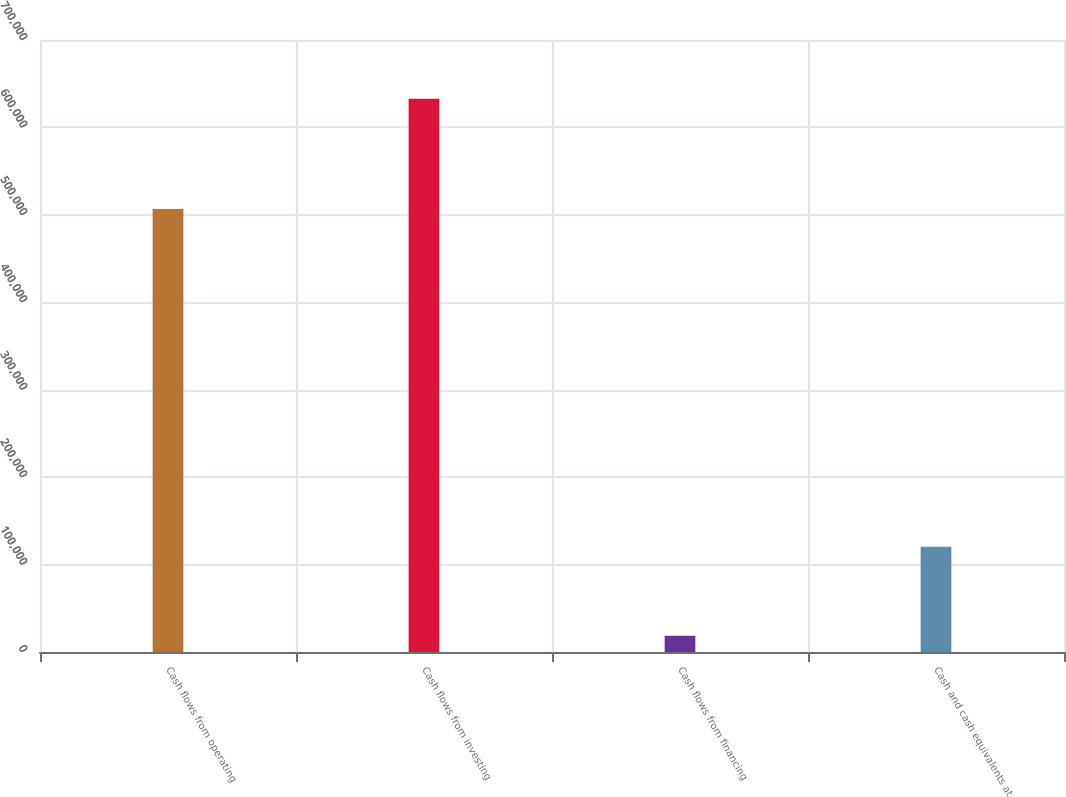Convert chart. <chart><loc_0><loc_0><loc_500><loc_500><bar_chart><fcel>Cash flows from operating<fcel>Cash flows from investing<fcel>Cash flows from financing<fcel>Cash and cash equivalents at<nl><fcel>506593<fcel>632750<fcel>18564<fcel>120526<nl></chart> 